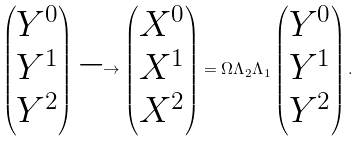Convert formula to latex. <formula><loc_0><loc_0><loc_500><loc_500>\begin{pmatrix} Y ^ { 0 } \\ Y ^ { 1 } \\ Y ^ { 2 } \end{pmatrix} \longrightarrow \begin{pmatrix} X ^ { 0 } \\ X ^ { 1 } \\ X ^ { 2 } \end{pmatrix} = \Omega \Lambda _ { 2 } \Lambda _ { 1 } \begin{pmatrix} Y ^ { 0 } \\ Y ^ { 1 } \\ Y ^ { 2 } \end{pmatrix} .</formula> 